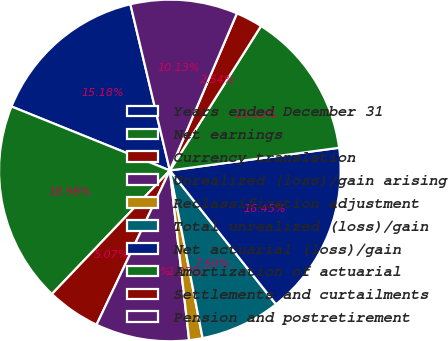Convert chart to OTSL. <chart><loc_0><loc_0><loc_500><loc_500><pie_chart><fcel>Years ended December 31<fcel>Net earnings<fcel>Currency translation<fcel>Unrealized (loss)/gain arising<fcel>Reclassification adjustment<fcel>Total unrealized (loss)/gain<fcel>Net actuarial (loss)/gain<fcel>Amortization of actuarial<fcel>Settlements and curtailments<fcel>Pension and postretirement<nl><fcel>15.18%<fcel>18.98%<fcel>5.07%<fcel>8.86%<fcel>1.27%<fcel>7.6%<fcel>16.45%<fcel>13.92%<fcel>2.54%<fcel>10.13%<nl></chart> 